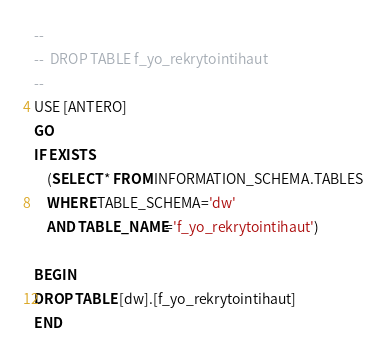<code> <loc_0><loc_0><loc_500><loc_500><_SQL_>--
--  DROP TABLE f_yo_rekrytointihaut
--
USE [ANTERO]
GO
IF EXISTS
	(SELECT * FROM INFORMATION_SCHEMA.TABLES
	WHERE TABLE_SCHEMA='dw'
	AND TABLE_NAME='f_yo_rekrytointihaut')

BEGIN
DROP TABLE [dw].[f_yo_rekrytointihaut]
END
</code> 